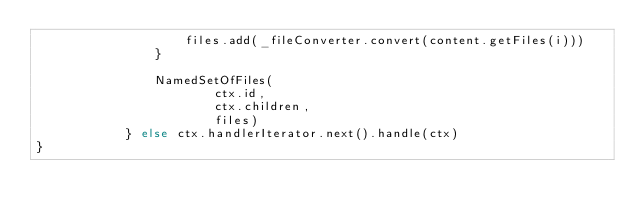Convert code to text. <code><loc_0><loc_0><loc_500><loc_500><_Kotlin_>                    files.add(_fileConverter.convert(content.getFiles(i)))
                }

                NamedSetOfFiles(
                        ctx.id,
                        ctx.children,
                        files)
            } else ctx.handlerIterator.next().handle(ctx)
}</code> 